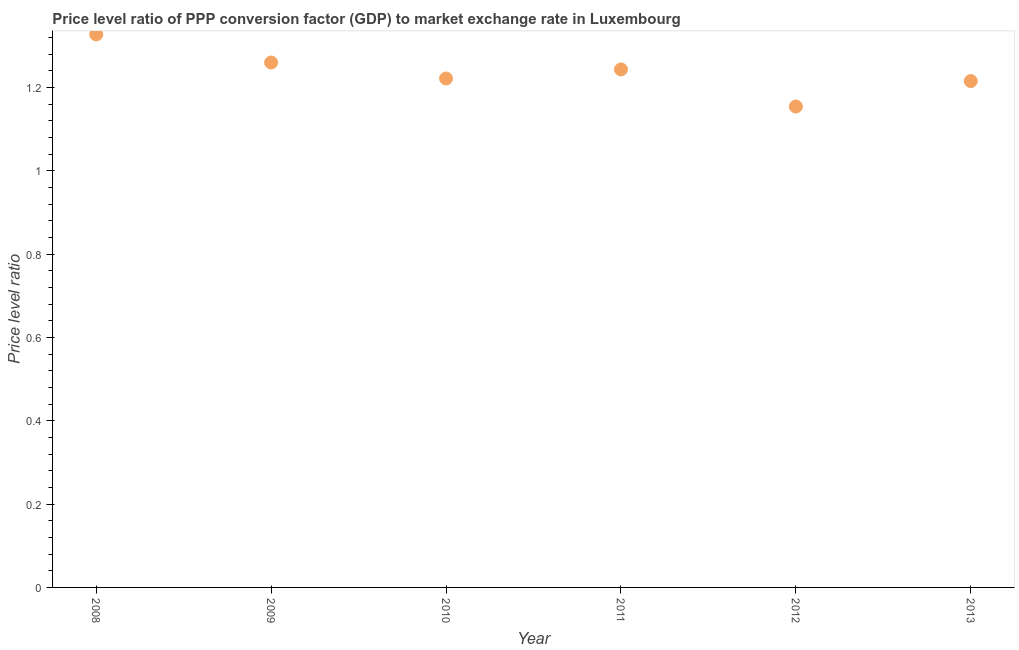What is the price level ratio in 2009?
Your answer should be very brief. 1.26. Across all years, what is the maximum price level ratio?
Your response must be concise. 1.33. Across all years, what is the minimum price level ratio?
Give a very brief answer. 1.15. In which year was the price level ratio minimum?
Keep it short and to the point. 2012. What is the sum of the price level ratio?
Ensure brevity in your answer.  7.42. What is the difference between the price level ratio in 2008 and 2012?
Your answer should be compact. 0.17. What is the average price level ratio per year?
Keep it short and to the point. 1.24. What is the median price level ratio?
Offer a very short reply. 1.23. In how many years, is the price level ratio greater than 0.28 ?
Offer a very short reply. 6. What is the ratio of the price level ratio in 2010 to that in 2011?
Your answer should be very brief. 0.98. What is the difference between the highest and the second highest price level ratio?
Your response must be concise. 0.07. What is the difference between the highest and the lowest price level ratio?
Provide a short and direct response. 0.17. Are the values on the major ticks of Y-axis written in scientific E-notation?
Your response must be concise. No. What is the title of the graph?
Provide a succinct answer. Price level ratio of PPP conversion factor (GDP) to market exchange rate in Luxembourg. What is the label or title of the X-axis?
Your answer should be compact. Year. What is the label or title of the Y-axis?
Provide a succinct answer. Price level ratio. What is the Price level ratio in 2008?
Your answer should be compact. 1.33. What is the Price level ratio in 2009?
Provide a short and direct response. 1.26. What is the Price level ratio in 2010?
Your answer should be compact. 1.22. What is the Price level ratio in 2011?
Give a very brief answer. 1.24. What is the Price level ratio in 2012?
Your response must be concise. 1.15. What is the Price level ratio in 2013?
Provide a succinct answer. 1.22. What is the difference between the Price level ratio in 2008 and 2009?
Offer a terse response. 0.07. What is the difference between the Price level ratio in 2008 and 2010?
Offer a terse response. 0.11. What is the difference between the Price level ratio in 2008 and 2011?
Offer a very short reply. 0.08. What is the difference between the Price level ratio in 2008 and 2012?
Provide a short and direct response. 0.17. What is the difference between the Price level ratio in 2008 and 2013?
Your answer should be compact. 0.11. What is the difference between the Price level ratio in 2009 and 2010?
Your answer should be compact. 0.04. What is the difference between the Price level ratio in 2009 and 2011?
Your response must be concise. 0.02. What is the difference between the Price level ratio in 2009 and 2012?
Your answer should be compact. 0.11. What is the difference between the Price level ratio in 2009 and 2013?
Offer a very short reply. 0.04. What is the difference between the Price level ratio in 2010 and 2011?
Keep it short and to the point. -0.02. What is the difference between the Price level ratio in 2010 and 2012?
Give a very brief answer. 0.07. What is the difference between the Price level ratio in 2010 and 2013?
Make the answer very short. 0.01. What is the difference between the Price level ratio in 2011 and 2012?
Your answer should be very brief. 0.09. What is the difference between the Price level ratio in 2011 and 2013?
Make the answer very short. 0.03. What is the difference between the Price level ratio in 2012 and 2013?
Offer a very short reply. -0.06. What is the ratio of the Price level ratio in 2008 to that in 2009?
Make the answer very short. 1.05. What is the ratio of the Price level ratio in 2008 to that in 2010?
Ensure brevity in your answer.  1.09. What is the ratio of the Price level ratio in 2008 to that in 2011?
Provide a succinct answer. 1.07. What is the ratio of the Price level ratio in 2008 to that in 2012?
Provide a succinct answer. 1.15. What is the ratio of the Price level ratio in 2008 to that in 2013?
Keep it short and to the point. 1.09. What is the ratio of the Price level ratio in 2009 to that in 2010?
Offer a terse response. 1.03. What is the ratio of the Price level ratio in 2009 to that in 2012?
Offer a very short reply. 1.09. What is the ratio of the Price level ratio in 2009 to that in 2013?
Keep it short and to the point. 1.04. What is the ratio of the Price level ratio in 2010 to that in 2011?
Ensure brevity in your answer.  0.98. What is the ratio of the Price level ratio in 2010 to that in 2012?
Ensure brevity in your answer.  1.06. What is the ratio of the Price level ratio in 2010 to that in 2013?
Your answer should be very brief. 1. What is the ratio of the Price level ratio in 2011 to that in 2012?
Your answer should be very brief. 1.08. What is the ratio of the Price level ratio in 2012 to that in 2013?
Keep it short and to the point. 0.95. 